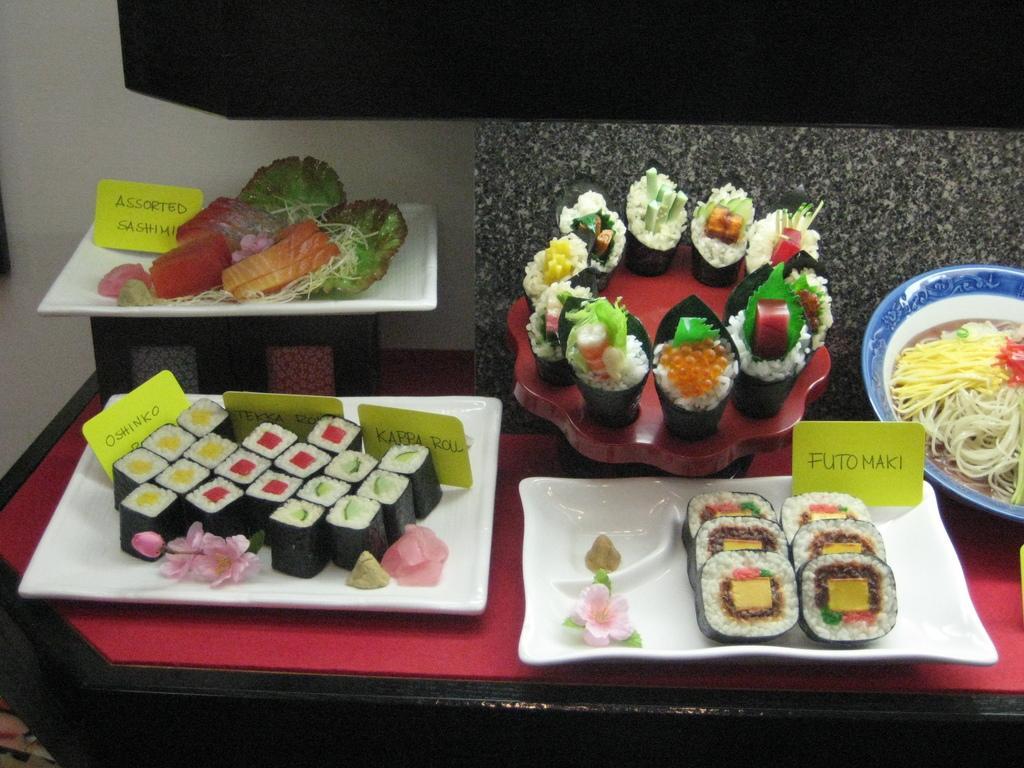Could you give a brief overview of what you see in this image? In this image we can see different food items in plates on the table. In the background of the image there is a wall. 